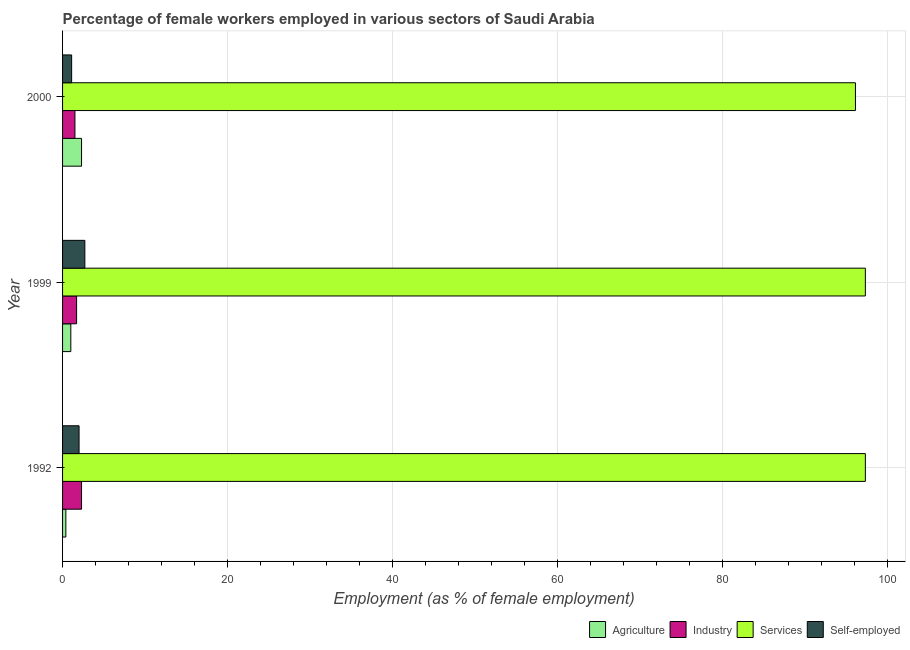How many different coloured bars are there?
Keep it short and to the point. 4. Are the number of bars per tick equal to the number of legend labels?
Provide a short and direct response. Yes. How many bars are there on the 1st tick from the top?
Provide a succinct answer. 4. How many bars are there on the 2nd tick from the bottom?
Offer a terse response. 4. What is the label of the 1st group of bars from the top?
Your answer should be very brief. 2000. In how many cases, is the number of bars for a given year not equal to the number of legend labels?
Offer a very short reply. 0. What is the percentage of female workers in services in 2000?
Keep it short and to the point. 96.1. Across all years, what is the maximum percentage of female workers in industry?
Your response must be concise. 2.3. Across all years, what is the minimum percentage of female workers in services?
Give a very brief answer. 96.1. In which year was the percentage of female workers in industry minimum?
Keep it short and to the point. 2000. What is the total percentage of female workers in services in the graph?
Offer a very short reply. 290.7. What is the difference between the percentage of female workers in industry in 1992 and that in 1999?
Your response must be concise. 0.6. What is the difference between the percentage of self employed female workers in 2000 and the percentage of female workers in services in 1992?
Give a very brief answer. -96.2. What is the average percentage of self employed female workers per year?
Your answer should be very brief. 1.93. In the year 1992, what is the difference between the percentage of female workers in services and percentage of female workers in agriculture?
Offer a terse response. 96.9. What is the ratio of the percentage of female workers in industry in 1992 to that in 2000?
Provide a short and direct response. 1.53. Is the percentage of female workers in industry in 1992 less than that in 1999?
Provide a succinct answer. No. Is the difference between the percentage of self employed female workers in 1992 and 2000 greater than the difference between the percentage of female workers in services in 1992 and 2000?
Your response must be concise. No. In how many years, is the percentage of female workers in agriculture greater than the average percentage of female workers in agriculture taken over all years?
Your answer should be compact. 1. Is it the case that in every year, the sum of the percentage of female workers in agriculture and percentage of female workers in services is greater than the sum of percentage of self employed female workers and percentage of female workers in industry?
Offer a terse response. No. What does the 1st bar from the top in 1999 represents?
Offer a very short reply. Self-employed. What does the 4th bar from the bottom in 2000 represents?
Make the answer very short. Self-employed. Is it the case that in every year, the sum of the percentage of female workers in agriculture and percentage of female workers in industry is greater than the percentage of female workers in services?
Provide a short and direct response. No. How many bars are there?
Keep it short and to the point. 12. Are all the bars in the graph horizontal?
Provide a short and direct response. Yes. How many years are there in the graph?
Provide a succinct answer. 3. What is the difference between two consecutive major ticks on the X-axis?
Offer a very short reply. 20. Does the graph contain grids?
Offer a very short reply. Yes. Where does the legend appear in the graph?
Your answer should be compact. Bottom right. How many legend labels are there?
Keep it short and to the point. 4. How are the legend labels stacked?
Make the answer very short. Horizontal. What is the title of the graph?
Give a very brief answer. Percentage of female workers employed in various sectors of Saudi Arabia. What is the label or title of the X-axis?
Offer a terse response. Employment (as % of female employment). What is the label or title of the Y-axis?
Your answer should be very brief. Year. What is the Employment (as % of female employment) of Agriculture in 1992?
Offer a terse response. 0.4. What is the Employment (as % of female employment) in Industry in 1992?
Give a very brief answer. 2.3. What is the Employment (as % of female employment) in Services in 1992?
Make the answer very short. 97.3. What is the Employment (as % of female employment) in Agriculture in 1999?
Your response must be concise. 1. What is the Employment (as % of female employment) of Industry in 1999?
Ensure brevity in your answer.  1.7. What is the Employment (as % of female employment) in Services in 1999?
Your answer should be compact. 97.3. What is the Employment (as % of female employment) in Self-employed in 1999?
Ensure brevity in your answer.  2.7. What is the Employment (as % of female employment) in Agriculture in 2000?
Your answer should be compact. 2.3. What is the Employment (as % of female employment) of Services in 2000?
Your response must be concise. 96.1. What is the Employment (as % of female employment) in Self-employed in 2000?
Ensure brevity in your answer.  1.1. Across all years, what is the maximum Employment (as % of female employment) of Agriculture?
Offer a very short reply. 2.3. Across all years, what is the maximum Employment (as % of female employment) in Industry?
Ensure brevity in your answer.  2.3. Across all years, what is the maximum Employment (as % of female employment) in Services?
Offer a very short reply. 97.3. Across all years, what is the maximum Employment (as % of female employment) in Self-employed?
Provide a short and direct response. 2.7. Across all years, what is the minimum Employment (as % of female employment) in Agriculture?
Offer a very short reply. 0.4. Across all years, what is the minimum Employment (as % of female employment) of Services?
Your response must be concise. 96.1. Across all years, what is the minimum Employment (as % of female employment) in Self-employed?
Offer a very short reply. 1.1. What is the total Employment (as % of female employment) of Agriculture in the graph?
Give a very brief answer. 3.7. What is the total Employment (as % of female employment) in Industry in the graph?
Your response must be concise. 5.5. What is the total Employment (as % of female employment) in Services in the graph?
Make the answer very short. 290.7. What is the total Employment (as % of female employment) in Self-employed in the graph?
Offer a terse response. 5.8. What is the difference between the Employment (as % of female employment) in Agriculture in 1992 and that in 1999?
Ensure brevity in your answer.  -0.6. What is the difference between the Employment (as % of female employment) of Industry in 1992 and that in 1999?
Keep it short and to the point. 0.6. What is the difference between the Employment (as % of female employment) in Services in 1992 and that in 1999?
Keep it short and to the point. 0. What is the difference between the Employment (as % of female employment) of Self-employed in 1992 and that in 1999?
Offer a very short reply. -0.7. What is the difference between the Employment (as % of female employment) of Agriculture in 1999 and that in 2000?
Provide a succinct answer. -1.3. What is the difference between the Employment (as % of female employment) of Services in 1999 and that in 2000?
Provide a short and direct response. 1.2. What is the difference between the Employment (as % of female employment) in Agriculture in 1992 and the Employment (as % of female employment) in Services in 1999?
Your response must be concise. -96.9. What is the difference between the Employment (as % of female employment) of Agriculture in 1992 and the Employment (as % of female employment) of Self-employed in 1999?
Give a very brief answer. -2.3. What is the difference between the Employment (as % of female employment) in Industry in 1992 and the Employment (as % of female employment) in Services in 1999?
Make the answer very short. -95. What is the difference between the Employment (as % of female employment) in Services in 1992 and the Employment (as % of female employment) in Self-employed in 1999?
Make the answer very short. 94.6. What is the difference between the Employment (as % of female employment) in Agriculture in 1992 and the Employment (as % of female employment) in Industry in 2000?
Make the answer very short. -1.1. What is the difference between the Employment (as % of female employment) in Agriculture in 1992 and the Employment (as % of female employment) in Services in 2000?
Offer a very short reply. -95.7. What is the difference between the Employment (as % of female employment) of Industry in 1992 and the Employment (as % of female employment) of Services in 2000?
Make the answer very short. -93.8. What is the difference between the Employment (as % of female employment) of Industry in 1992 and the Employment (as % of female employment) of Self-employed in 2000?
Offer a terse response. 1.2. What is the difference between the Employment (as % of female employment) of Services in 1992 and the Employment (as % of female employment) of Self-employed in 2000?
Keep it short and to the point. 96.2. What is the difference between the Employment (as % of female employment) of Agriculture in 1999 and the Employment (as % of female employment) of Services in 2000?
Offer a very short reply. -95.1. What is the difference between the Employment (as % of female employment) in Agriculture in 1999 and the Employment (as % of female employment) in Self-employed in 2000?
Your answer should be compact. -0.1. What is the difference between the Employment (as % of female employment) in Industry in 1999 and the Employment (as % of female employment) in Services in 2000?
Offer a very short reply. -94.4. What is the difference between the Employment (as % of female employment) in Industry in 1999 and the Employment (as % of female employment) in Self-employed in 2000?
Provide a short and direct response. 0.6. What is the difference between the Employment (as % of female employment) of Services in 1999 and the Employment (as % of female employment) of Self-employed in 2000?
Offer a very short reply. 96.2. What is the average Employment (as % of female employment) of Agriculture per year?
Your answer should be compact. 1.23. What is the average Employment (as % of female employment) in Industry per year?
Keep it short and to the point. 1.83. What is the average Employment (as % of female employment) of Services per year?
Provide a succinct answer. 96.9. What is the average Employment (as % of female employment) in Self-employed per year?
Your response must be concise. 1.93. In the year 1992, what is the difference between the Employment (as % of female employment) of Agriculture and Employment (as % of female employment) of Industry?
Your response must be concise. -1.9. In the year 1992, what is the difference between the Employment (as % of female employment) in Agriculture and Employment (as % of female employment) in Services?
Provide a succinct answer. -96.9. In the year 1992, what is the difference between the Employment (as % of female employment) of Agriculture and Employment (as % of female employment) of Self-employed?
Offer a very short reply. -1.6. In the year 1992, what is the difference between the Employment (as % of female employment) in Industry and Employment (as % of female employment) in Services?
Your answer should be compact. -95. In the year 1992, what is the difference between the Employment (as % of female employment) of Services and Employment (as % of female employment) of Self-employed?
Your answer should be compact. 95.3. In the year 1999, what is the difference between the Employment (as % of female employment) of Agriculture and Employment (as % of female employment) of Industry?
Ensure brevity in your answer.  -0.7. In the year 1999, what is the difference between the Employment (as % of female employment) in Agriculture and Employment (as % of female employment) in Services?
Provide a succinct answer. -96.3. In the year 1999, what is the difference between the Employment (as % of female employment) in Agriculture and Employment (as % of female employment) in Self-employed?
Provide a short and direct response. -1.7. In the year 1999, what is the difference between the Employment (as % of female employment) of Industry and Employment (as % of female employment) of Services?
Provide a short and direct response. -95.6. In the year 1999, what is the difference between the Employment (as % of female employment) in Services and Employment (as % of female employment) in Self-employed?
Offer a very short reply. 94.6. In the year 2000, what is the difference between the Employment (as % of female employment) in Agriculture and Employment (as % of female employment) in Services?
Your response must be concise. -93.8. In the year 2000, what is the difference between the Employment (as % of female employment) in Agriculture and Employment (as % of female employment) in Self-employed?
Provide a succinct answer. 1.2. In the year 2000, what is the difference between the Employment (as % of female employment) in Industry and Employment (as % of female employment) in Services?
Keep it short and to the point. -94.6. In the year 2000, what is the difference between the Employment (as % of female employment) of Industry and Employment (as % of female employment) of Self-employed?
Offer a very short reply. 0.4. What is the ratio of the Employment (as % of female employment) of Agriculture in 1992 to that in 1999?
Offer a very short reply. 0.4. What is the ratio of the Employment (as % of female employment) of Industry in 1992 to that in 1999?
Give a very brief answer. 1.35. What is the ratio of the Employment (as % of female employment) of Self-employed in 1992 to that in 1999?
Provide a succinct answer. 0.74. What is the ratio of the Employment (as % of female employment) of Agriculture in 1992 to that in 2000?
Offer a very short reply. 0.17. What is the ratio of the Employment (as % of female employment) in Industry in 1992 to that in 2000?
Provide a succinct answer. 1.53. What is the ratio of the Employment (as % of female employment) in Services in 1992 to that in 2000?
Your answer should be very brief. 1.01. What is the ratio of the Employment (as % of female employment) of Self-employed in 1992 to that in 2000?
Your response must be concise. 1.82. What is the ratio of the Employment (as % of female employment) in Agriculture in 1999 to that in 2000?
Offer a very short reply. 0.43. What is the ratio of the Employment (as % of female employment) of Industry in 1999 to that in 2000?
Provide a short and direct response. 1.13. What is the ratio of the Employment (as % of female employment) in Services in 1999 to that in 2000?
Provide a succinct answer. 1.01. What is the ratio of the Employment (as % of female employment) in Self-employed in 1999 to that in 2000?
Provide a succinct answer. 2.45. What is the difference between the highest and the second highest Employment (as % of female employment) of Agriculture?
Ensure brevity in your answer.  1.3. What is the difference between the highest and the second highest Employment (as % of female employment) of Industry?
Offer a very short reply. 0.6. What is the difference between the highest and the second highest Employment (as % of female employment) in Self-employed?
Keep it short and to the point. 0.7. What is the difference between the highest and the lowest Employment (as % of female employment) of Industry?
Make the answer very short. 0.8. What is the difference between the highest and the lowest Employment (as % of female employment) of Services?
Keep it short and to the point. 1.2. 